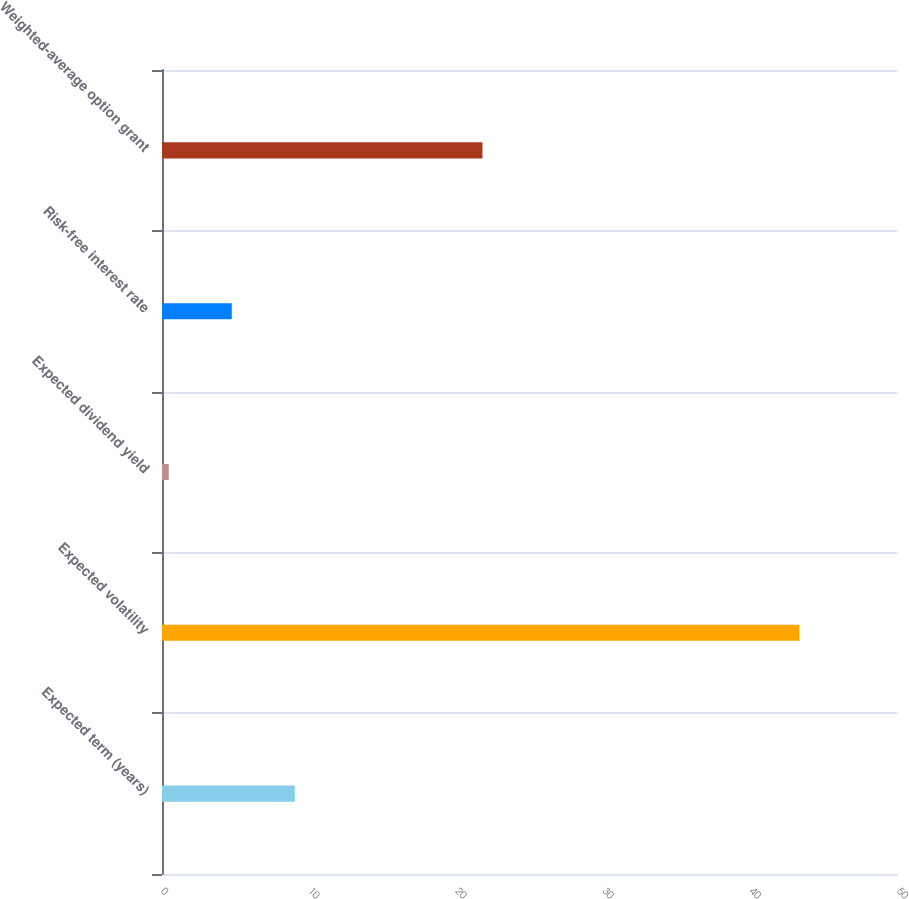Convert chart to OTSL. <chart><loc_0><loc_0><loc_500><loc_500><bar_chart><fcel>Expected term (years)<fcel>Expected volatility<fcel>Expected dividend yield<fcel>Risk-free interest rate<fcel>Weighted-average option grant<nl><fcel>9.02<fcel>43.3<fcel>0.46<fcel>4.74<fcel>21.77<nl></chart> 